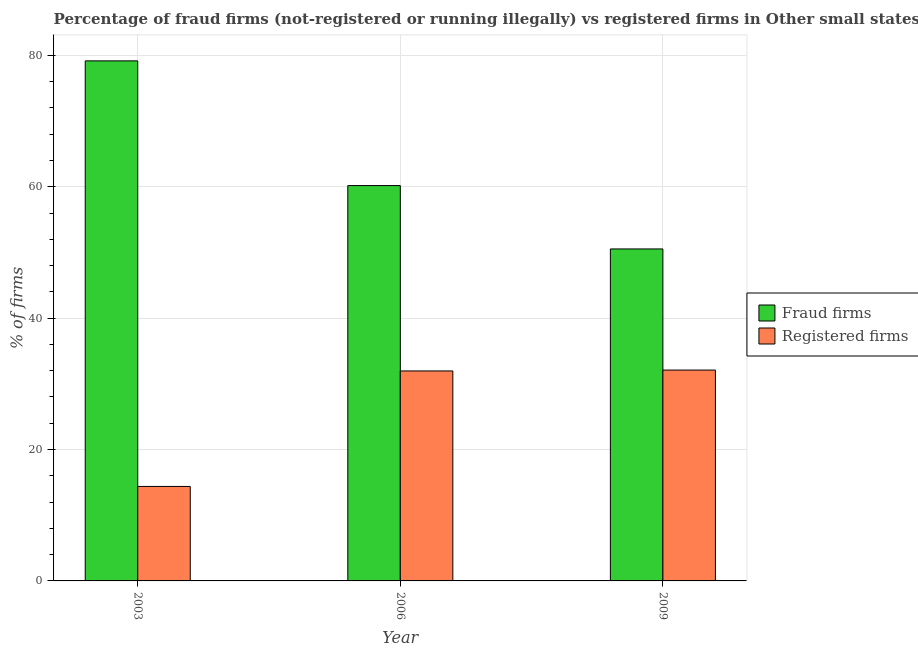Are the number of bars per tick equal to the number of legend labels?
Your response must be concise. Yes. Are the number of bars on each tick of the X-axis equal?
Your response must be concise. Yes. What is the percentage of fraud firms in 2006?
Ensure brevity in your answer.  60.19. Across all years, what is the maximum percentage of registered firms?
Your answer should be very brief. 32.1. Across all years, what is the minimum percentage of fraud firms?
Make the answer very short. 50.54. In which year was the percentage of registered firms maximum?
Provide a short and direct response. 2009. What is the total percentage of registered firms in the graph?
Offer a very short reply. 78.45. What is the difference between the percentage of fraud firms in 2003 and that in 2006?
Make the answer very short. 18.98. What is the difference between the percentage of registered firms in 2009 and the percentage of fraud firms in 2003?
Give a very brief answer. 17.72. What is the average percentage of fraud firms per year?
Your answer should be compact. 63.3. In the year 2006, what is the difference between the percentage of fraud firms and percentage of registered firms?
Your answer should be compact. 0. In how many years, is the percentage of registered firms greater than 52 %?
Make the answer very short. 0. What is the ratio of the percentage of registered firms in 2003 to that in 2006?
Offer a terse response. 0.45. What is the difference between the highest and the second highest percentage of fraud firms?
Ensure brevity in your answer.  18.98. What is the difference between the highest and the lowest percentage of registered firms?
Provide a succinct answer. 17.72. In how many years, is the percentage of fraud firms greater than the average percentage of fraud firms taken over all years?
Your response must be concise. 1. What does the 2nd bar from the left in 2009 represents?
Give a very brief answer. Registered firms. What does the 2nd bar from the right in 2009 represents?
Make the answer very short. Fraud firms. How many bars are there?
Your response must be concise. 6. Are all the bars in the graph horizontal?
Provide a short and direct response. No. What is the difference between two consecutive major ticks on the Y-axis?
Make the answer very short. 20. Does the graph contain any zero values?
Keep it short and to the point. No. What is the title of the graph?
Provide a short and direct response. Percentage of fraud firms (not-registered or running illegally) vs registered firms in Other small states. Does "Female labor force" appear as one of the legend labels in the graph?
Provide a short and direct response. No. What is the label or title of the Y-axis?
Offer a very short reply. % of firms. What is the % of firms in Fraud firms in 2003?
Offer a very short reply. 79.17. What is the % of firms in Registered firms in 2003?
Your answer should be compact. 14.38. What is the % of firms of Fraud firms in 2006?
Your answer should be very brief. 60.19. What is the % of firms of Registered firms in 2006?
Make the answer very short. 31.97. What is the % of firms in Fraud firms in 2009?
Offer a very short reply. 50.54. What is the % of firms in Registered firms in 2009?
Your answer should be very brief. 32.1. Across all years, what is the maximum % of firms of Fraud firms?
Provide a succinct answer. 79.17. Across all years, what is the maximum % of firms of Registered firms?
Your response must be concise. 32.1. Across all years, what is the minimum % of firms of Fraud firms?
Make the answer very short. 50.54. Across all years, what is the minimum % of firms of Registered firms?
Give a very brief answer. 14.38. What is the total % of firms in Fraud firms in the graph?
Provide a short and direct response. 189.9. What is the total % of firms in Registered firms in the graph?
Provide a succinct answer. 78.45. What is the difference between the % of firms of Fraud firms in 2003 and that in 2006?
Your answer should be very brief. 18.98. What is the difference between the % of firms in Registered firms in 2003 and that in 2006?
Offer a terse response. -17.58. What is the difference between the % of firms of Fraud firms in 2003 and that in 2009?
Your answer should be very brief. 28.63. What is the difference between the % of firms of Registered firms in 2003 and that in 2009?
Your answer should be very brief. -17.72. What is the difference between the % of firms of Fraud firms in 2006 and that in 2009?
Your answer should be very brief. 9.65. What is the difference between the % of firms of Registered firms in 2006 and that in 2009?
Your response must be concise. -0.13. What is the difference between the % of firms of Fraud firms in 2003 and the % of firms of Registered firms in 2006?
Offer a terse response. 47.2. What is the difference between the % of firms in Fraud firms in 2003 and the % of firms in Registered firms in 2009?
Offer a terse response. 47.07. What is the difference between the % of firms of Fraud firms in 2006 and the % of firms of Registered firms in 2009?
Provide a succinct answer. 28.09. What is the average % of firms of Fraud firms per year?
Offer a very short reply. 63.3. What is the average % of firms in Registered firms per year?
Your answer should be very brief. 26.15. In the year 2003, what is the difference between the % of firms in Fraud firms and % of firms in Registered firms?
Ensure brevity in your answer.  64.79. In the year 2006, what is the difference between the % of firms of Fraud firms and % of firms of Registered firms?
Your answer should be very brief. 28.22. In the year 2009, what is the difference between the % of firms in Fraud firms and % of firms in Registered firms?
Offer a terse response. 18.44. What is the ratio of the % of firms of Fraud firms in 2003 to that in 2006?
Provide a succinct answer. 1.32. What is the ratio of the % of firms of Registered firms in 2003 to that in 2006?
Provide a short and direct response. 0.45. What is the ratio of the % of firms of Fraud firms in 2003 to that in 2009?
Keep it short and to the point. 1.57. What is the ratio of the % of firms in Registered firms in 2003 to that in 2009?
Provide a succinct answer. 0.45. What is the ratio of the % of firms in Fraud firms in 2006 to that in 2009?
Ensure brevity in your answer.  1.19. What is the difference between the highest and the second highest % of firms of Fraud firms?
Offer a very short reply. 18.98. What is the difference between the highest and the second highest % of firms of Registered firms?
Keep it short and to the point. 0.13. What is the difference between the highest and the lowest % of firms in Fraud firms?
Give a very brief answer. 28.63. What is the difference between the highest and the lowest % of firms of Registered firms?
Provide a succinct answer. 17.72. 